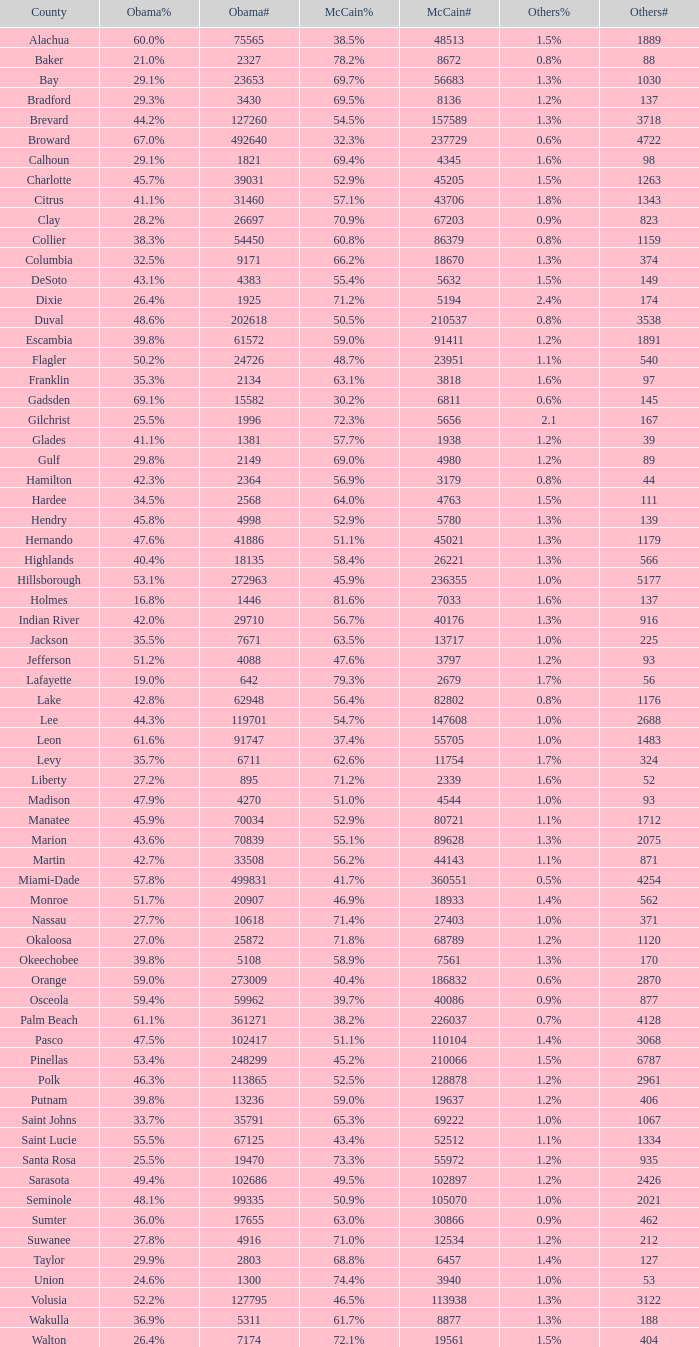How many voters did mccain have when obama had 895 voters? 2339.0. 